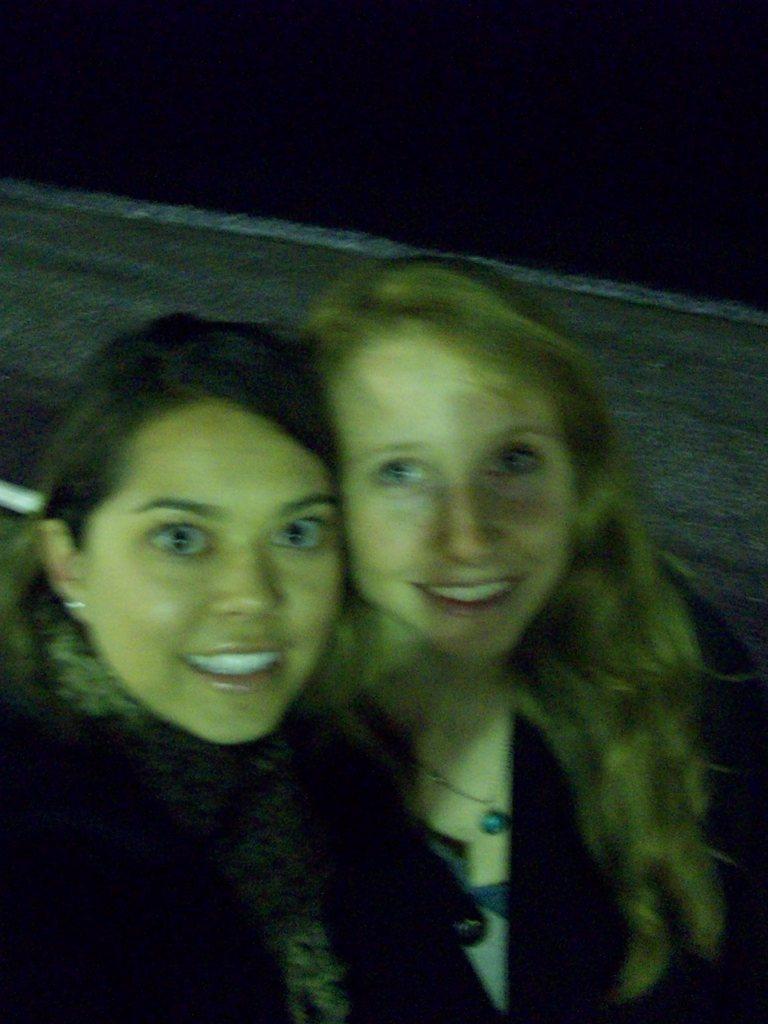Describe this image in one or two sentences. In this picture, we can see two women. In the background, there is black color. 